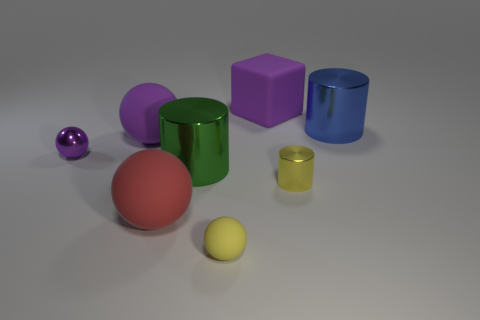Add 2 blue shiny things. How many objects exist? 10 Subtract all cubes. How many objects are left? 7 Add 7 small blue things. How many small blue things exist? 7 Subtract 0 cyan cubes. How many objects are left? 8 Subtract all big blue metallic blocks. Subtract all tiny matte objects. How many objects are left? 7 Add 2 tiny shiny things. How many tiny shiny things are left? 4 